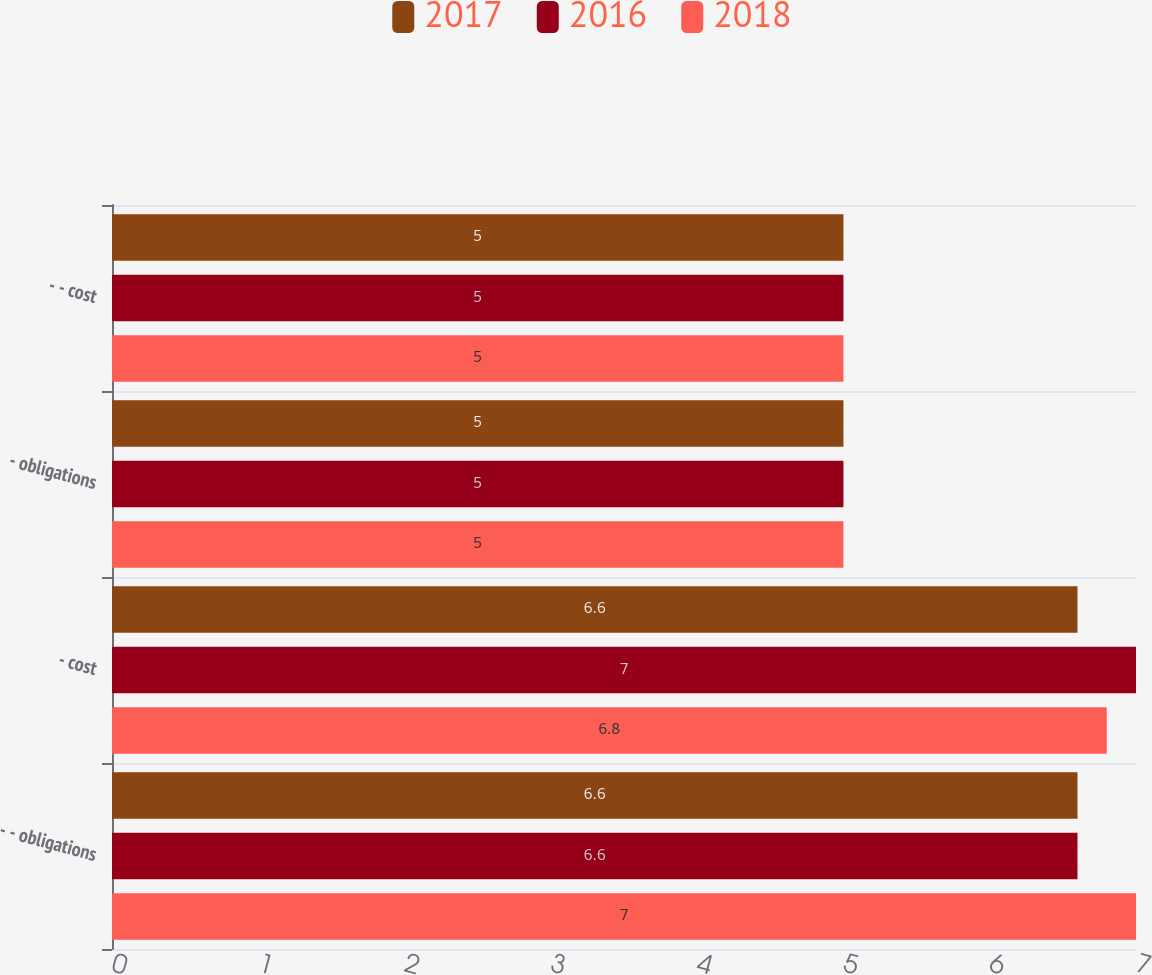Convert chart. <chart><loc_0><loc_0><loc_500><loc_500><stacked_bar_chart><ecel><fcel>- - obligations<fcel>- cost<fcel>- obligations<fcel>- - cost<nl><fcel>2017<fcel>6.6<fcel>6.6<fcel>5<fcel>5<nl><fcel>2016<fcel>6.6<fcel>7<fcel>5<fcel>5<nl><fcel>2018<fcel>7<fcel>6.8<fcel>5<fcel>5<nl></chart> 